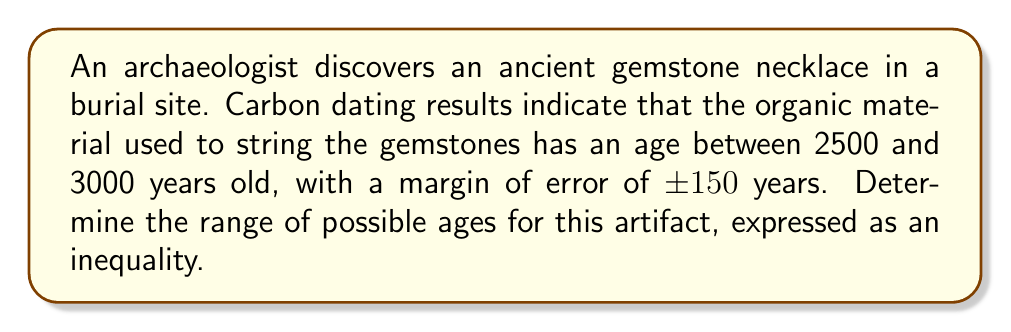Can you solve this math problem? Let's approach this step-by-step:

1) Let $x$ represent the actual age of the artifact in years.

2) The carbon dating results give us a range of 2500 to 3000 years, with a margin of error of ±150 years.

3) For the lower bound:
   - Minimum age: 2500 years
   - Subtract the margin of error: 2500 - 150 = 2350 years

4) For the upper bound:
   - Maximum age: 3000 years
   - Add the margin of error: 3000 + 150 = 3150 years

5) Therefore, the actual age $x$ must be greater than or equal to 2350 years and less than or equal to 3150 years.

6) We can express this as an inequality:

   $$2350 \leq x \leq 3150$$

This inequality represents the range of possible ages for the ancient gemstone necklace, taking into account the carbon dating results and the margin of error.
Answer: $2350 \leq x \leq 3150$ 